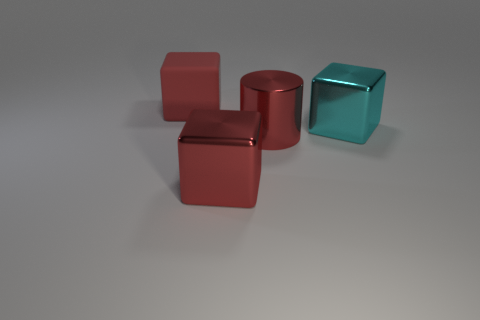Add 2 tiny yellow metal things. How many objects exist? 6 Subtract all blocks. How many objects are left? 1 Subtract all large cyan things. Subtract all red metallic cubes. How many objects are left? 2 Add 3 red things. How many red things are left? 6 Add 1 large rubber objects. How many large rubber objects exist? 2 Subtract 1 red cubes. How many objects are left? 3 